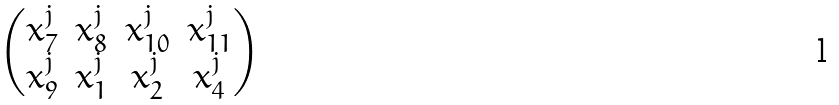Convert formula to latex. <formula><loc_0><loc_0><loc_500><loc_500>\begin{pmatrix} x _ { 7 } ^ { j } & x _ { 8 } ^ { j } & x _ { 1 0 } ^ { j } & x _ { 1 1 } ^ { j } \\ x _ { 9 } ^ { j } & x _ { 1 } ^ { j } & x _ { 2 } ^ { j } & x _ { 4 } ^ { j } \end{pmatrix}</formula> 